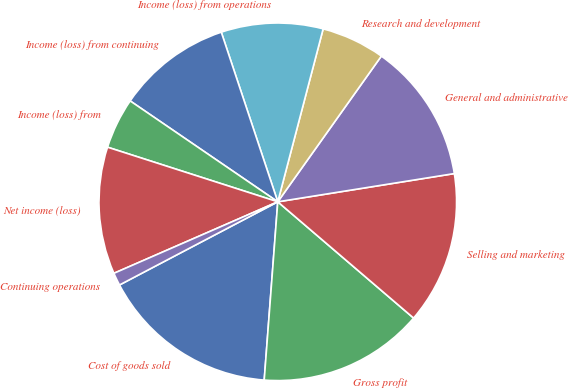Convert chart. <chart><loc_0><loc_0><loc_500><loc_500><pie_chart><fcel>Cost of goods sold<fcel>Gross profit<fcel>Selling and marketing<fcel>General and administrative<fcel>Research and development<fcel>Income (loss) from operations<fcel>Income (loss) from continuing<fcel>Income (loss) from<fcel>Net income (loss)<fcel>Continuing operations<nl><fcel>16.09%<fcel>14.94%<fcel>13.79%<fcel>12.64%<fcel>5.75%<fcel>9.2%<fcel>10.34%<fcel>4.6%<fcel>11.49%<fcel>1.15%<nl></chart> 